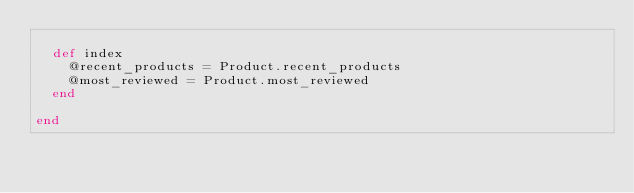Convert code to text. <code><loc_0><loc_0><loc_500><loc_500><_Ruby_>
  def index
    @recent_products = Product.recent_products
    @most_reviewed = Product.most_reviewed
  end

end
</code> 